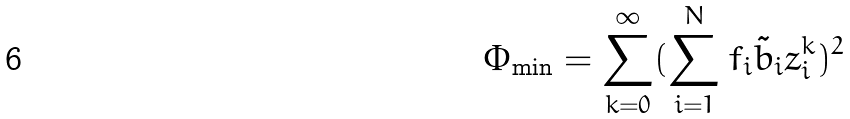Convert formula to latex. <formula><loc_0><loc_0><loc_500><loc_500>\Phi _ { \min } = \sum ^ { \infty } _ { k = 0 } ( \sum ^ { N } _ { i = 1 } f _ { i } \tilde { b } _ { i } z ^ { k } _ { i } ) ^ { 2 }</formula> 